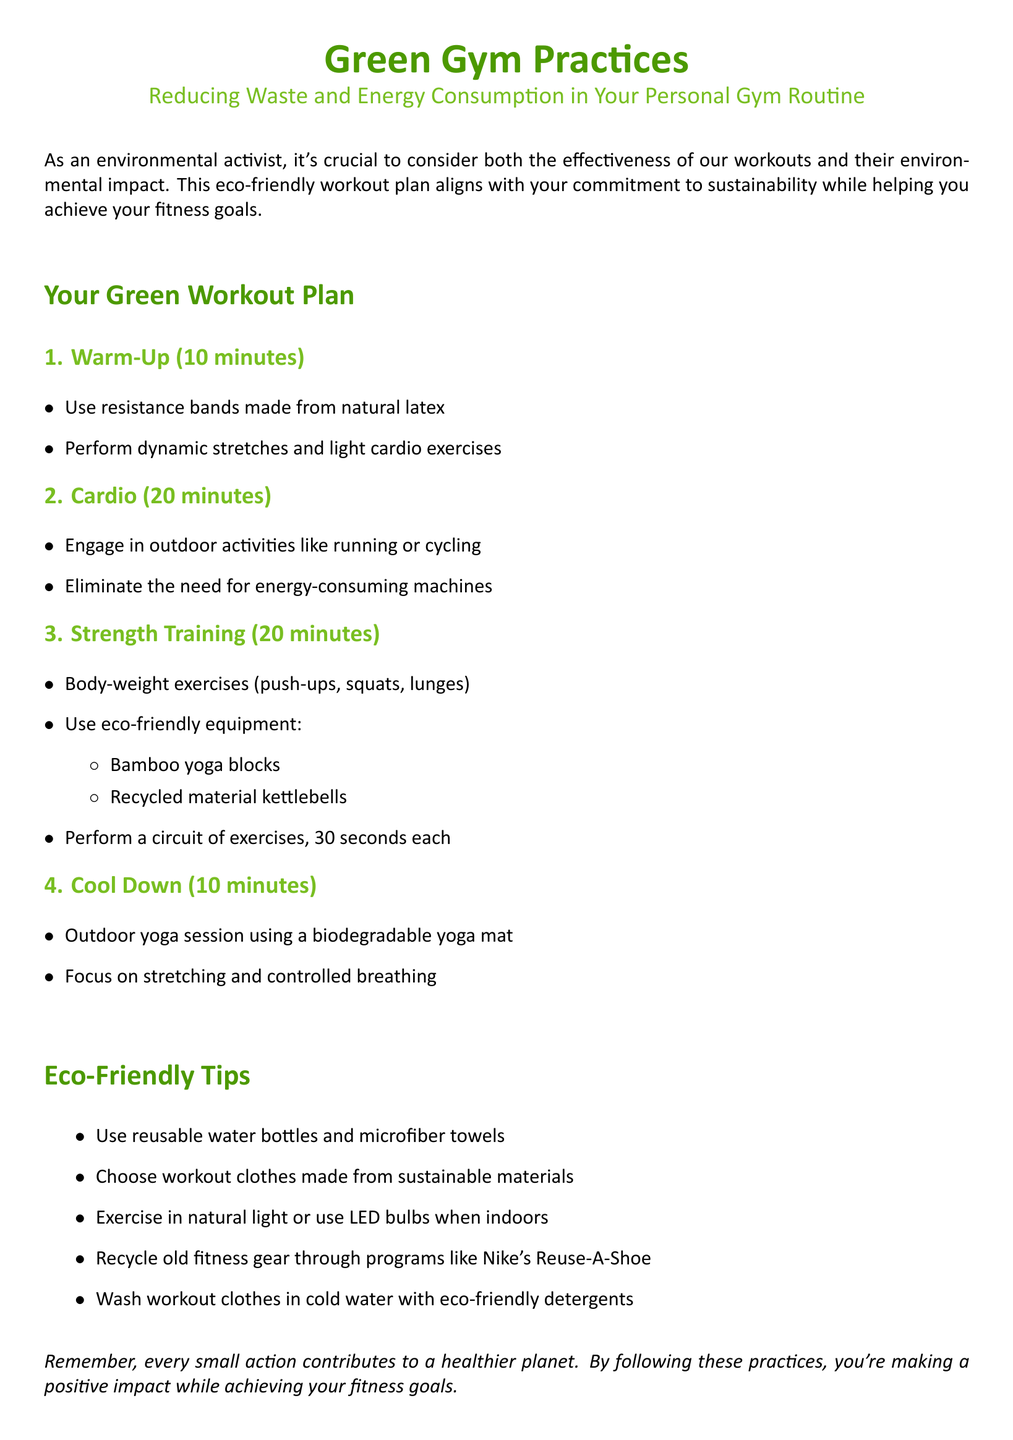what is the duration of the warm-up? The warm-up duration is specified at the beginning of the workout plan.
Answer: 10 minutes what type of yoga mat is suggested for the outdoor yoga session? The document indicates the type of yoga mat recommended for the outdoor yoga session.
Answer: Biodegradable yoga mat how long is the cardio section of the workout plan? The cardio section duration is specified in the workout plan.
Answer: 20 minutes what sustainable material is recommended for workout clothes? The document suggests using clothes made from specific sustainable materials.
Answer: Sustainable materials which gear recycling program is mentioned in the tips? The recycling program for old fitness gear is noted in the eco-friendly tips section.
Answer: Nike's Reuse-A-Shoe what exercise equipment is made from recycled materials? The document lists eco-friendly equipment including items made from recycled materials.
Answer: Recycled material kettlebells how long is the cool-down period in the workout plan? The duration of the cool-down period is stated in the workout plan.
Answer: 10 minutes what activity is suggested for outdoor cardio? The document recommends specific outdoor activities for the cardio section.
Answer: Running or cycling which eco-friendly item is advised for hydration during workouts? The eco-friendly tip section provides suggestions for hydration items.
Answer: Reusable water bottles 